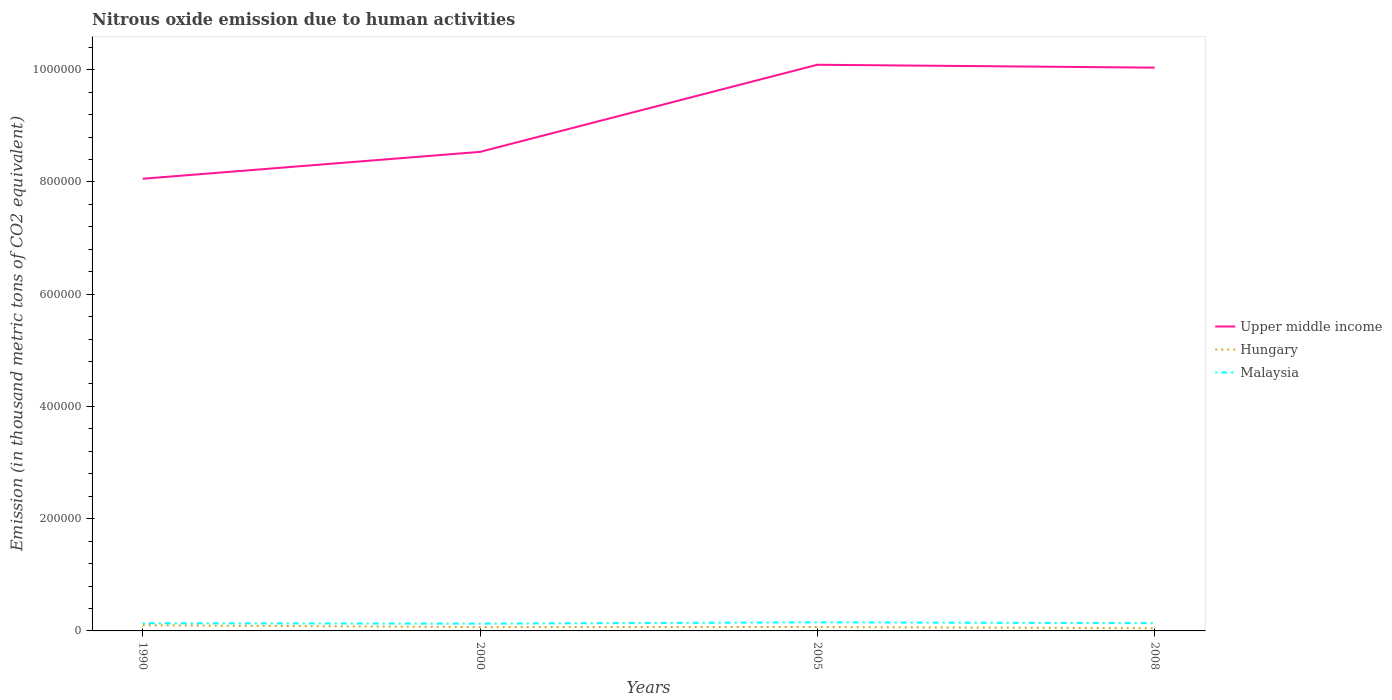How many different coloured lines are there?
Give a very brief answer. 3. Does the line corresponding to Hungary intersect with the line corresponding to Upper middle income?
Your answer should be very brief. No. Is the number of lines equal to the number of legend labels?
Ensure brevity in your answer.  Yes. Across all years, what is the maximum amount of nitrous oxide emitted in Hungary?
Make the answer very short. 4840.8. What is the total amount of nitrous oxide emitted in Upper middle income in the graph?
Ensure brevity in your answer.  -1.55e+05. What is the difference between the highest and the second highest amount of nitrous oxide emitted in Upper middle income?
Provide a succinct answer. 2.03e+05. What is the difference between the highest and the lowest amount of nitrous oxide emitted in Upper middle income?
Give a very brief answer. 2. Is the amount of nitrous oxide emitted in Upper middle income strictly greater than the amount of nitrous oxide emitted in Hungary over the years?
Provide a short and direct response. No. How many years are there in the graph?
Give a very brief answer. 4. What is the difference between two consecutive major ticks on the Y-axis?
Offer a very short reply. 2.00e+05. Are the values on the major ticks of Y-axis written in scientific E-notation?
Keep it short and to the point. No. Does the graph contain any zero values?
Keep it short and to the point. No. How many legend labels are there?
Ensure brevity in your answer.  3. How are the legend labels stacked?
Your response must be concise. Vertical. What is the title of the graph?
Your answer should be very brief. Nitrous oxide emission due to human activities. What is the label or title of the X-axis?
Provide a succinct answer. Years. What is the label or title of the Y-axis?
Your response must be concise. Emission (in thousand metric tons of CO2 equivalent). What is the Emission (in thousand metric tons of CO2 equivalent) of Upper middle income in 1990?
Your answer should be very brief. 8.06e+05. What is the Emission (in thousand metric tons of CO2 equivalent) of Hungary in 1990?
Ensure brevity in your answer.  1.01e+04. What is the Emission (in thousand metric tons of CO2 equivalent) of Malaysia in 1990?
Your answer should be very brief. 1.36e+04. What is the Emission (in thousand metric tons of CO2 equivalent) of Upper middle income in 2000?
Offer a terse response. 8.54e+05. What is the Emission (in thousand metric tons of CO2 equivalent) in Hungary in 2000?
Provide a succinct answer. 6855.8. What is the Emission (in thousand metric tons of CO2 equivalent) of Malaysia in 2000?
Your answer should be very brief. 1.29e+04. What is the Emission (in thousand metric tons of CO2 equivalent) in Upper middle income in 2005?
Your response must be concise. 1.01e+06. What is the Emission (in thousand metric tons of CO2 equivalent) of Hungary in 2005?
Your response must be concise. 6974.6. What is the Emission (in thousand metric tons of CO2 equivalent) in Malaysia in 2005?
Your answer should be very brief. 1.53e+04. What is the Emission (in thousand metric tons of CO2 equivalent) in Upper middle income in 2008?
Your answer should be compact. 1.00e+06. What is the Emission (in thousand metric tons of CO2 equivalent) in Hungary in 2008?
Make the answer very short. 4840.8. What is the Emission (in thousand metric tons of CO2 equivalent) of Malaysia in 2008?
Offer a very short reply. 1.38e+04. Across all years, what is the maximum Emission (in thousand metric tons of CO2 equivalent) of Upper middle income?
Offer a terse response. 1.01e+06. Across all years, what is the maximum Emission (in thousand metric tons of CO2 equivalent) in Hungary?
Offer a terse response. 1.01e+04. Across all years, what is the maximum Emission (in thousand metric tons of CO2 equivalent) of Malaysia?
Provide a succinct answer. 1.53e+04. Across all years, what is the minimum Emission (in thousand metric tons of CO2 equivalent) in Upper middle income?
Offer a terse response. 8.06e+05. Across all years, what is the minimum Emission (in thousand metric tons of CO2 equivalent) in Hungary?
Your answer should be compact. 4840.8. Across all years, what is the minimum Emission (in thousand metric tons of CO2 equivalent) in Malaysia?
Keep it short and to the point. 1.29e+04. What is the total Emission (in thousand metric tons of CO2 equivalent) of Upper middle income in the graph?
Keep it short and to the point. 3.67e+06. What is the total Emission (in thousand metric tons of CO2 equivalent) of Hungary in the graph?
Make the answer very short. 2.88e+04. What is the total Emission (in thousand metric tons of CO2 equivalent) in Malaysia in the graph?
Provide a short and direct response. 5.56e+04. What is the difference between the Emission (in thousand metric tons of CO2 equivalent) in Upper middle income in 1990 and that in 2000?
Your response must be concise. -4.79e+04. What is the difference between the Emission (in thousand metric tons of CO2 equivalent) in Hungary in 1990 and that in 2000?
Your response must be concise. 3258.4. What is the difference between the Emission (in thousand metric tons of CO2 equivalent) in Malaysia in 1990 and that in 2000?
Ensure brevity in your answer.  651.9. What is the difference between the Emission (in thousand metric tons of CO2 equivalent) of Upper middle income in 1990 and that in 2005?
Ensure brevity in your answer.  -2.03e+05. What is the difference between the Emission (in thousand metric tons of CO2 equivalent) of Hungary in 1990 and that in 2005?
Offer a terse response. 3139.6. What is the difference between the Emission (in thousand metric tons of CO2 equivalent) of Malaysia in 1990 and that in 2005?
Provide a short and direct response. -1747.4. What is the difference between the Emission (in thousand metric tons of CO2 equivalent) of Upper middle income in 1990 and that in 2008?
Provide a short and direct response. -1.98e+05. What is the difference between the Emission (in thousand metric tons of CO2 equivalent) of Hungary in 1990 and that in 2008?
Offer a very short reply. 5273.4. What is the difference between the Emission (in thousand metric tons of CO2 equivalent) in Malaysia in 1990 and that in 2008?
Provide a short and direct response. -169.4. What is the difference between the Emission (in thousand metric tons of CO2 equivalent) of Upper middle income in 2000 and that in 2005?
Make the answer very short. -1.55e+05. What is the difference between the Emission (in thousand metric tons of CO2 equivalent) of Hungary in 2000 and that in 2005?
Offer a terse response. -118.8. What is the difference between the Emission (in thousand metric tons of CO2 equivalent) in Malaysia in 2000 and that in 2005?
Your answer should be compact. -2399.3. What is the difference between the Emission (in thousand metric tons of CO2 equivalent) of Upper middle income in 2000 and that in 2008?
Ensure brevity in your answer.  -1.50e+05. What is the difference between the Emission (in thousand metric tons of CO2 equivalent) in Hungary in 2000 and that in 2008?
Make the answer very short. 2015. What is the difference between the Emission (in thousand metric tons of CO2 equivalent) of Malaysia in 2000 and that in 2008?
Provide a succinct answer. -821.3. What is the difference between the Emission (in thousand metric tons of CO2 equivalent) of Upper middle income in 2005 and that in 2008?
Give a very brief answer. 5159.9. What is the difference between the Emission (in thousand metric tons of CO2 equivalent) of Hungary in 2005 and that in 2008?
Provide a short and direct response. 2133.8. What is the difference between the Emission (in thousand metric tons of CO2 equivalent) in Malaysia in 2005 and that in 2008?
Offer a very short reply. 1578. What is the difference between the Emission (in thousand metric tons of CO2 equivalent) in Upper middle income in 1990 and the Emission (in thousand metric tons of CO2 equivalent) in Hungary in 2000?
Ensure brevity in your answer.  7.99e+05. What is the difference between the Emission (in thousand metric tons of CO2 equivalent) of Upper middle income in 1990 and the Emission (in thousand metric tons of CO2 equivalent) of Malaysia in 2000?
Offer a terse response. 7.93e+05. What is the difference between the Emission (in thousand metric tons of CO2 equivalent) of Hungary in 1990 and the Emission (in thousand metric tons of CO2 equivalent) of Malaysia in 2000?
Ensure brevity in your answer.  -2830.1. What is the difference between the Emission (in thousand metric tons of CO2 equivalent) in Upper middle income in 1990 and the Emission (in thousand metric tons of CO2 equivalent) in Hungary in 2005?
Give a very brief answer. 7.99e+05. What is the difference between the Emission (in thousand metric tons of CO2 equivalent) of Upper middle income in 1990 and the Emission (in thousand metric tons of CO2 equivalent) of Malaysia in 2005?
Provide a short and direct response. 7.90e+05. What is the difference between the Emission (in thousand metric tons of CO2 equivalent) of Hungary in 1990 and the Emission (in thousand metric tons of CO2 equivalent) of Malaysia in 2005?
Your answer should be very brief. -5229.4. What is the difference between the Emission (in thousand metric tons of CO2 equivalent) in Upper middle income in 1990 and the Emission (in thousand metric tons of CO2 equivalent) in Hungary in 2008?
Provide a short and direct response. 8.01e+05. What is the difference between the Emission (in thousand metric tons of CO2 equivalent) in Upper middle income in 1990 and the Emission (in thousand metric tons of CO2 equivalent) in Malaysia in 2008?
Make the answer very short. 7.92e+05. What is the difference between the Emission (in thousand metric tons of CO2 equivalent) of Hungary in 1990 and the Emission (in thousand metric tons of CO2 equivalent) of Malaysia in 2008?
Your response must be concise. -3651.4. What is the difference between the Emission (in thousand metric tons of CO2 equivalent) in Upper middle income in 2000 and the Emission (in thousand metric tons of CO2 equivalent) in Hungary in 2005?
Offer a terse response. 8.47e+05. What is the difference between the Emission (in thousand metric tons of CO2 equivalent) in Upper middle income in 2000 and the Emission (in thousand metric tons of CO2 equivalent) in Malaysia in 2005?
Ensure brevity in your answer.  8.38e+05. What is the difference between the Emission (in thousand metric tons of CO2 equivalent) in Hungary in 2000 and the Emission (in thousand metric tons of CO2 equivalent) in Malaysia in 2005?
Your answer should be compact. -8487.8. What is the difference between the Emission (in thousand metric tons of CO2 equivalent) of Upper middle income in 2000 and the Emission (in thousand metric tons of CO2 equivalent) of Hungary in 2008?
Provide a short and direct response. 8.49e+05. What is the difference between the Emission (in thousand metric tons of CO2 equivalent) of Upper middle income in 2000 and the Emission (in thousand metric tons of CO2 equivalent) of Malaysia in 2008?
Make the answer very short. 8.40e+05. What is the difference between the Emission (in thousand metric tons of CO2 equivalent) in Hungary in 2000 and the Emission (in thousand metric tons of CO2 equivalent) in Malaysia in 2008?
Keep it short and to the point. -6909.8. What is the difference between the Emission (in thousand metric tons of CO2 equivalent) in Upper middle income in 2005 and the Emission (in thousand metric tons of CO2 equivalent) in Hungary in 2008?
Provide a short and direct response. 1.00e+06. What is the difference between the Emission (in thousand metric tons of CO2 equivalent) of Upper middle income in 2005 and the Emission (in thousand metric tons of CO2 equivalent) of Malaysia in 2008?
Your response must be concise. 9.95e+05. What is the difference between the Emission (in thousand metric tons of CO2 equivalent) of Hungary in 2005 and the Emission (in thousand metric tons of CO2 equivalent) of Malaysia in 2008?
Provide a succinct answer. -6791. What is the average Emission (in thousand metric tons of CO2 equivalent) of Upper middle income per year?
Make the answer very short. 9.18e+05. What is the average Emission (in thousand metric tons of CO2 equivalent) in Hungary per year?
Keep it short and to the point. 7196.35. What is the average Emission (in thousand metric tons of CO2 equivalent) in Malaysia per year?
Provide a succinct answer. 1.39e+04. In the year 1990, what is the difference between the Emission (in thousand metric tons of CO2 equivalent) of Upper middle income and Emission (in thousand metric tons of CO2 equivalent) of Hungary?
Give a very brief answer. 7.96e+05. In the year 1990, what is the difference between the Emission (in thousand metric tons of CO2 equivalent) in Upper middle income and Emission (in thousand metric tons of CO2 equivalent) in Malaysia?
Your answer should be very brief. 7.92e+05. In the year 1990, what is the difference between the Emission (in thousand metric tons of CO2 equivalent) in Hungary and Emission (in thousand metric tons of CO2 equivalent) in Malaysia?
Your answer should be very brief. -3482. In the year 2000, what is the difference between the Emission (in thousand metric tons of CO2 equivalent) of Upper middle income and Emission (in thousand metric tons of CO2 equivalent) of Hungary?
Make the answer very short. 8.47e+05. In the year 2000, what is the difference between the Emission (in thousand metric tons of CO2 equivalent) in Upper middle income and Emission (in thousand metric tons of CO2 equivalent) in Malaysia?
Your answer should be compact. 8.41e+05. In the year 2000, what is the difference between the Emission (in thousand metric tons of CO2 equivalent) in Hungary and Emission (in thousand metric tons of CO2 equivalent) in Malaysia?
Provide a succinct answer. -6088.5. In the year 2005, what is the difference between the Emission (in thousand metric tons of CO2 equivalent) of Upper middle income and Emission (in thousand metric tons of CO2 equivalent) of Hungary?
Your response must be concise. 1.00e+06. In the year 2005, what is the difference between the Emission (in thousand metric tons of CO2 equivalent) of Upper middle income and Emission (in thousand metric tons of CO2 equivalent) of Malaysia?
Give a very brief answer. 9.93e+05. In the year 2005, what is the difference between the Emission (in thousand metric tons of CO2 equivalent) of Hungary and Emission (in thousand metric tons of CO2 equivalent) of Malaysia?
Offer a terse response. -8369. In the year 2008, what is the difference between the Emission (in thousand metric tons of CO2 equivalent) of Upper middle income and Emission (in thousand metric tons of CO2 equivalent) of Hungary?
Provide a succinct answer. 9.99e+05. In the year 2008, what is the difference between the Emission (in thousand metric tons of CO2 equivalent) in Upper middle income and Emission (in thousand metric tons of CO2 equivalent) in Malaysia?
Your response must be concise. 9.90e+05. In the year 2008, what is the difference between the Emission (in thousand metric tons of CO2 equivalent) in Hungary and Emission (in thousand metric tons of CO2 equivalent) in Malaysia?
Your answer should be very brief. -8924.8. What is the ratio of the Emission (in thousand metric tons of CO2 equivalent) of Upper middle income in 1990 to that in 2000?
Keep it short and to the point. 0.94. What is the ratio of the Emission (in thousand metric tons of CO2 equivalent) of Hungary in 1990 to that in 2000?
Make the answer very short. 1.48. What is the ratio of the Emission (in thousand metric tons of CO2 equivalent) of Malaysia in 1990 to that in 2000?
Keep it short and to the point. 1.05. What is the ratio of the Emission (in thousand metric tons of CO2 equivalent) in Upper middle income in 1990 to that in 2005?
Ensure brevity in your answer.  0.8. What is the ratio of the Emission (in thousand metric tons of CO2 equivalent) in Hungary in 1990 to that in 2005?
Your answer should be very brief. 1.45. What is the ratio of the Emission (in thousand metric tons of CO2 equivalent) in Malaysia in 1990 to that in 2005?
Give a very brief answer. 0.89. What is the ratio of the Emission (in thousand metric tons of CO2 equivalent) in Upper middle income in 1990 to that in 2008?
Keep it short and to the point. 0.8. What is the ratio of the Emission (in thousand metric tons of CO2 equivalent) in Hungary in 1990 to that in 2008?
Provide a succinct answer. 2.09. What is the ratio of the Emission (in thousand metric tons of CO2 equivalent) of Upper middle income in 2000 to that in 2005?
Your response must be concise. 0.85. What is the ratio of the Emission (in thousand metric tons of CO2 equivalent) of Hungary in 2000 to that in 2005?
Provide a short and direct response. 0.98. What is the ratio of the Emission (in thousand metric tons of CO2 equivalent) of Malaysia in 2000 to that in 2005?
Your answer should be very brief. 0.84. What is the ratio of the Emission (in thousand metric tons of CO2 equivalent) in Upper middle income in 2000 to that in 2008?
Your response must be concise. 0.85. What is the ratio of the Emission (in thousand metric tons of CO2 equivalent) in Hungary in 2000 to that in 2008?
Your answer should be compact. 1.42. What is the ratio of the Emission (in thousand metric tons of CO2 equivalent) of Malaysia in 2000 to that in 2008?
Keep it short and to the point. 0.94. What is the ratio of the Emission (in thousand metric tons of CO2 equivalent) of Hungary in 2005 to that in 2008?
Provide a succinct answer. 1.44. What is the ratio of the Emission (in thousand metric tons of CO2 equivalent) of Malaysia in 2005 to that in 2008?
Your answer should be very brief. 1.11. What is the difference between the highest and the second highest Emission (in thousand metric tons of CO2 equivalent) in Upper middle income?
Your response must be concise. 5159.9. What is the difference between the highest and the second highest Emission (in thousand metric tons of CO2 equivalent) of Hungary?
Offer a very short reply. 3139.6. What is the difference between the highest and the second highest Emission (in thousand metric tons of CO2 equivalent) in Malaysia?
Your answer should be compact. 1578. What is the difference between the highest and the lowest Emission (in thousand metric tons of CO2 equivalent) of Upper middle income?
Give a very brief answer. 2.03e+05. What is the difference between the highest and the lowest Emission (in thousand metric tons of CO2 equivalent) in Hungary?
Offer a terse response. 5273.4. What is the difference between the highest and the lowest Emission (in thousand metric tons of CO2 equivalent) in Malaysia?
Ensure brevity in your answer.  2399.3. 